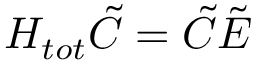<formula> <loc_0><loc_0><loc_500><loc_500>H _ { t o t } \tilde { C } = \tilde { C } \tilde { E }</formula> 